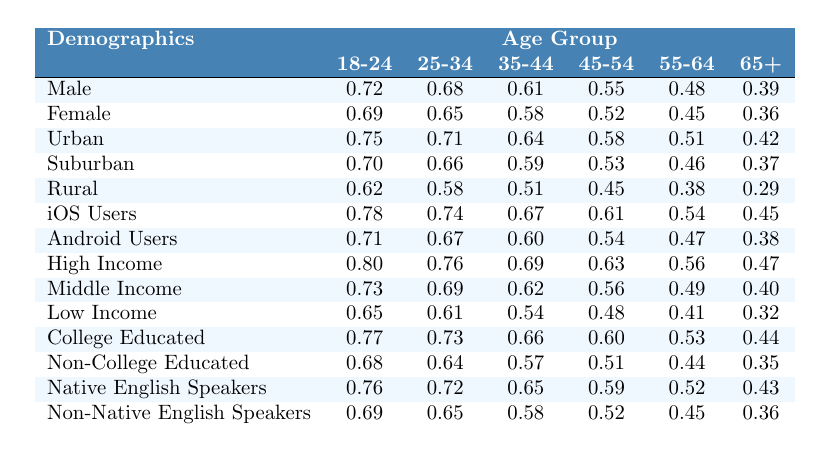What is the male adoption rate for the age group 25-34? The table shows the male adoption rate for the age group 25-34 is 0.68.
Answer: 0.68 What is the female adoption rate for users aged 65 and older? According to the table, the female adoption rate for the age group 65+ is 0.36.
Answer: 0.36 Which age group has the highest adoption rate among high-income users? The high-income adoption rate is highest in the age group 18-24 with a value of 0.80.
Answer: 0.80 What is the difference between the adoption rate of iOS users and Android users in the age group 45-54? The iOS adoption rate is 0.61 and the Android adoption rate is 0.54 for the age group 45-54; the difference is 0.61 - 0.54 = 0.07.
Answer: 0.07 What is the average adoption rate for college-educated users across all age groups? The adoption rates for college-educated users are 0.77, 0.73, 0.66, 0.60, 0.53, and 0.44. Their sum is 0.77 + 0.73 + 0.66 + 0.60 + 0.53 + 0.44 = 3.73, and the average is 3.73 / 6 = 0.62167, rounded to 0.62.
Answer: 0.62 Is the adoption rate of native English speakers higher than for non-native English speakers in the age group 55-64? For the age group 55-64, the adoption rate for native English speakers is 0.52, while for non-native speakers, it is 0.45. Thus, the statement is true.
Answer: Yes Which demographic has the lowest adoption rate in the age group 65+? In the age group 65+, the demographic with the lowest adoption rate is rural users with a rate of 0.29.
Answer: 0.29 What overall trend can be observed in adoption rates as age increases? As the age groups increase, the adoption rates for both males and females generally decrease, indicating a downward trend.
Answer: Downward trend What is the total adoption rate for middle-income users across all age groups? The middle-income adoption rates sum up to 0.73 + 0.69 + 0.62 + 0.56 + 0.49 + 0.40 = 3.49 for six age groups combined.
Answer: 3.49 In which area is the lowest adoption rate found - rural, suburban, or urban for the age group 35-44? The rural adoption rate for the age group 35-44 is 0.51, while suburban and urban rates are 0.59 and 0.64 respectively. Thus, rural has the lowest adoption rate.
Answer: Rural How does the adoption rate for low-income users compare between the age groups 25-34 and 45-54? The low-income adoption rates are 0.61 for the age group 25-34 and 0.48 for the age group 45-54, showing a decrease of 0.13.
Answer: Decrease of 0.13 